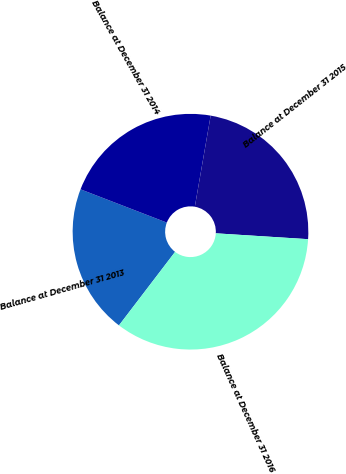Convert chart. <chart><loc_0><loc_0><loc_500><loc_500><pie_chart><fcel>Balance at December 31 2013<fcel>Balance at December 31 2014<fcel>Balance at December 31 2015<fcel>Balance at December 31 2016<nl><fcel>20.48%<fcel>21.88%<fcel>23.27%<fcel>34.37%<nl></chart> 